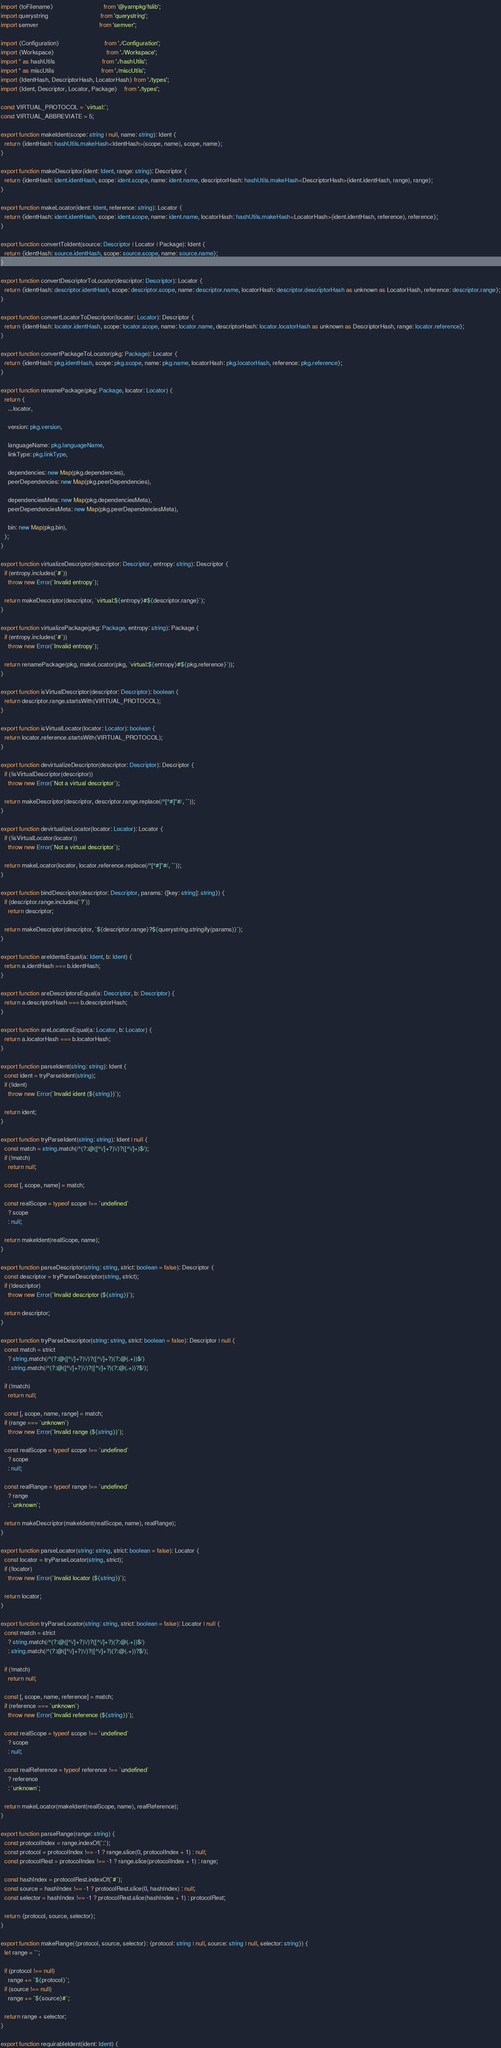Convert code to text. <code><loc_0><loc_0><loc_500><loc_500><_TypeScript_>import {toFilename}                             from '@yarnpkg/fslib';
import querystring                              from 'querystring';
import semver                                   from 'semver';

import {Configuration}                          from './Configuration';
import {Workspace}                              from './Workspace';
import * as hashUtils                           from './hashUtils';
import * as miscUtils                           from './miscUtils';
import {IdentHash, DescriptorHash, LocatorHash} from './types';
import {Ident, Descriptor, Locator, Package}    from './types';

const VIRTUAL_PROTOCOL = `virtual:`;
const VIRTUAL_ABBREVIATE = 5;

export function makeIdent(scope: string | null, name: string): Ident {
  return {identHash: hashUtils.makeHash<IdentHash>(scope, name), scope, name};
}

export function makeDescriptor(ident: Ident, range: string): Descriptor {
  return {identHash: ident.identHash, scope: ident.scope, name: ident.name, descriptorHash: hashUtils.makeHash<DescriptorHash>(ident.identHash, range), range};
}

export function makeLocator(ident: Ident, reference: string): Locator {
  return {identHash: ident.identHash, scope: ident.scope, name: ident.name, locatorHash: hashUtils.makeHash<LocatorHash>(ident.identHash, reference), reference};
}

export function convertToIdent(source: Descriptor | Locator | Package): Ident {
  return {identHash: source.identHash, scope: source.scope, name: source.name};
}

export function convertDescriptorToLocator(descriptor: Descriptor): Locator {
  return {identHash: descriptor.identHash, scope: descriptor.scope, name: descriptor.name, locatorHash: descriptor.descriptorHash as unknown as LocatorHash, reference: descriptor.range};
}

export function convertLocatorToDescriptor(locator: Locator): Descriptor {
  return {identHash: locator.identHash, scope: locator.scope, name: locator.name, descriptorHash: locator.locatorHash as unknown as DescriptorHash, range: locator.reference};
}

export function convertPackageToLocator(pkg: Package): Locator {
  return {identHash: pkg.identHash, scope: pkg.scope, name: pkg.name, locatorHash: pkg.locatorHash, reference: pkg.reference};
}

export function renamePackage(pkg: Package, locator: Locator) {
  return {
    ...locator,

    version: pkg.version,

    languageName: pkg.languageName,
    linkType: pkg.linkType,

    dependencies: new Map(pkg.dependencies),
    peerDependencies: new Map(pkg.peerDependencies),

    dependenciesMeta: new Map(pkg.dependenciesMeta),
    peerDependenciesMeta: new Map(pkg.peerDependenciesMeta),

    bin: new Map(pkg.bin),
  };
}

export function virtualizeDescriptor(descriptor: Descriptor, entropy: string): Descriptor {
  if (entropy.includes(`#`))
    throw new Error(`Invalid entropy`);

  return makeDescriptor(descriptor, `virtual:${entropy}#${descriptor.range}`);
}

export function virtualizePackage(pkg: Package, entropy: string): Package {
  if (entropy.includes(`#`))
    throw new Error(`Invalid entropy`);

  return renamePackage(pkg, makeLocator(pkg, `virtual:${entropy}#${pkg.reference}`));
}

export function isVirtualDescriptor(descriptor: Descriptor): boolean {
  return descriptor.range.startsWith(VIRTUAL_PROTOCOL);
}

export function isVirtualLocator(locator: Locator): boolean {
  return locator.reference.startsWith(VIRTUAL_PROTOCOL);
}

export function devirtualizeDescriptor(descriptor: Descriptor): Descriptor {
  if (!isVirtualDescriptor(descriptor))
    throw new Error(`Not a virtual descriptor`);

  return makeDescriptor(descriptor, descriptor.range.replace(/^[^#]*#/, ``));
}

export function devirtualizeLocator(locator: Locator): Locator {
  if (!isVirtualLocator(locator))
    throw new Error(`Not a virtual descriptor`);

  return makeLocator(locator, locator.reference.replace(/^[^#]*#/, ``));
}

export function bindDescriptor(descriptor: Descriptor, params: {[key: string]: string}) {
  if (descriptor.range.includes(`?`))
    return descriptor;

  return makeDescriptor(descriptor, `${descriptor.range}?${querystring.stringify(params)}`);
}

export function areIdentsEqual(a: Ident, b: Ident) {
  return a.identHash === b.identHash;
}

export function areDescriptorsEqual(a: Descriptor, b: Descriptor) {
  return a.descriptorHash === b.descriptorHash;
}

export function areLocatorsEqual(a: Locator, b: Locator) {
  return a.locatorHash === b.locatorHash;
}

export function parseIdent(string: string): Ident {
  const ident = tryParseIdent(string);
  if (!ident)
    throw new Error(`Invalid ident (${string})`);

  return ident;
}

export function tryParseIdent(string: string): Ident | null {
  const match = string.match(/^(?:@([^\/]+?)\/)?([^\/]+)$/);
  if (!match)
    return null;

  const [, scope, name] = match;

  const realScope = typeof scope !== `undefined`
    ? scope
    : null;

  return makeIdent(realScope, name);
}

export function parseDescriptor(string: string, strict: boolean = false): Descriptor {
  const descriptor = tryParseDescriptor(string, strict);
  if (!descriptor)
    throw new Error(`Invalid descriptor (${string})`);

  return descriptor;
}

export function tryParseDescriptor(string: string, strict: boolean = false): Descriptor | null {
  const match = strict
    ? string.match(/^(?:@([^\/]+?)\/)?([^\/]+?)(?:@(.+))$/)
    : string.match(/^(?:@([^\/]+?)\/)?([^\/]+?)(?:@(.+))?$/);

  if (!match)
    return null;

  const [, scope, name, range] = match;
  if (range === `unknown`)
    throw new Error(`Invalid range (${string})`);

  const realScope = typeof scope !== `undefined`
    ? scope
    : null;

  const realRange = typeof range !== `undefined`
    ? range
    : `unknown`;

  return makeDescriptor(makeIdent(realScope, name), realRange);
}

export function parseLocator(string: string, strict: boolean = false): Locator {
  const locator = tryParseLocator(string, strict);
  if (!locator)
    throw new Error(`Invalid locator (${string})`);

  return locator;
}

export function tryParseLocator(string: string, strict: boolean = false): Locator | null {
  const match = strict
    ? string.match(/^(?:@([^\/]+?)\/)?([^\/]+?)(?:@(.+))$/)
    : string.match(/^(?:@([^\/]+?)\/)?([^\/]+?)(?:@(.+))?$/);

  if (!match)
    return null;

  const [, scope, name, reference] = match;
  if (reference === `unknown`)
    throw new Error(`Invalid reference (${string})`);

  const realScope = typeof scope !== `undefined`
    ? scope
    : null;

  const realReference = typeof reference !== `undefined`
    ? reference
    : `unknown`;

  return makeLocator(makeIdent(realScope, name), realReference);
}

export function parseRange(range: string) {
  const protocolIndex = range.indexOf(`:`);
  const protocol = protocolIndex !== -1 ? range.slice(0, protocolIndex + 1) : null;
  const protocolRest = protocolIndex !== -1 ? range.slice(protocolIndex + 1) : range;

  const hashIndex = protocolRest.indexOf(`#`);
  const source = hashIndex !== -1 ? protocolRest.slice(0, hashIndex) : null;
  const selector = hashIndex !== -1 ? protocolRest.slice(hashIndex + 1) : protocolRest;

  return {protocol, source, selector};
}

export function makeRange({protocol, source, selector}: {protocol: string | null, source: string | null, selector: string}) {
  let range = ``;

  if (protocol !== null)
    range += `${protocol}`;
  if (source !== null)
    range += `${source}#`;

  return range + selector;
}

export function requirableIdent(ident: Ident) {</code> 